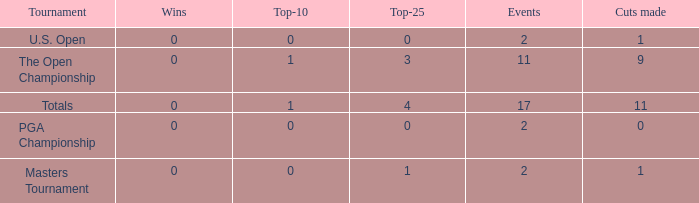What is his low win total when he has over 3 top 25s and under 9 cuts made? None. 